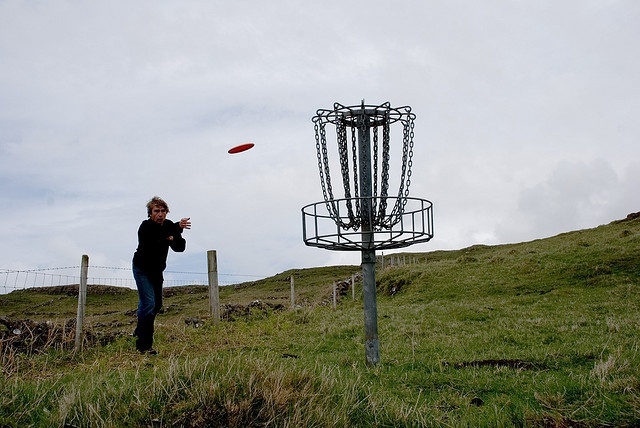Describe the objects in this image and their specific colors. I can see people in lightgray, black, maroon, and gray tones and frisbee in lightgray, maroon, and brown tones in this image. 